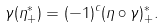Convert formula to latex. <formula><loc_0><loc_0><loc_500><loc_500>\gamma ( \eta ^ { * } _ { + } ) = ( - 1 ) ^ { c } ( \eta \circ \gamma ) ^ { * } _ { + } .</formula> 